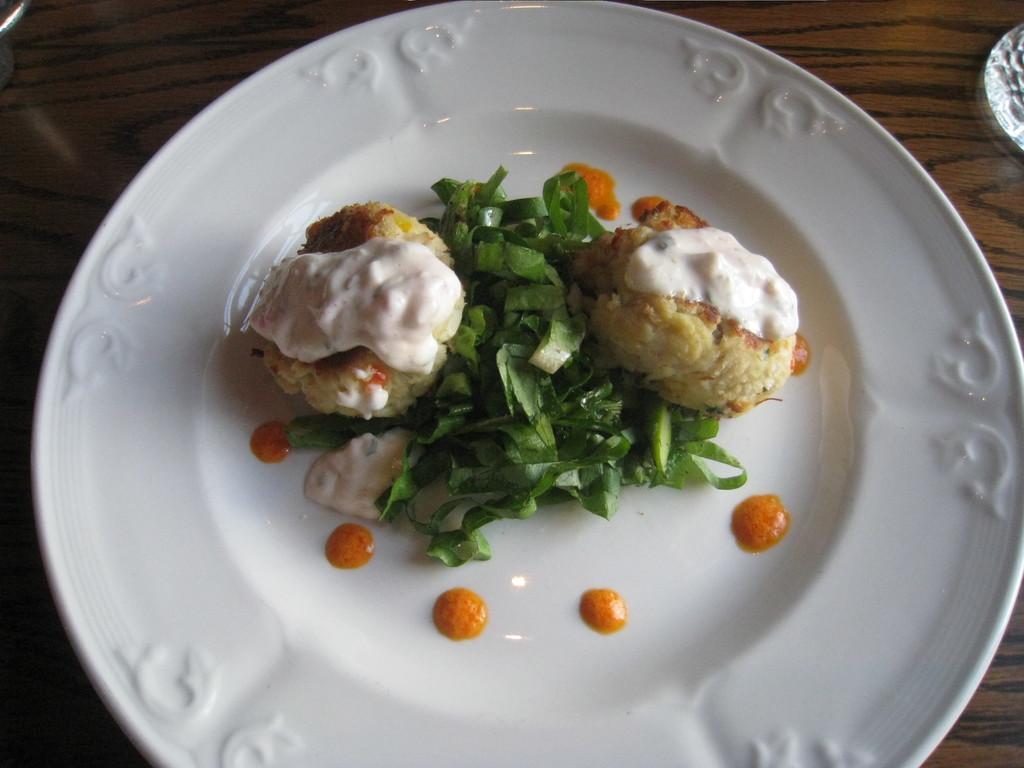Could you give a brief overview of what you see in this image? In the image there is some cooked food along with some leaves served on a plate. 